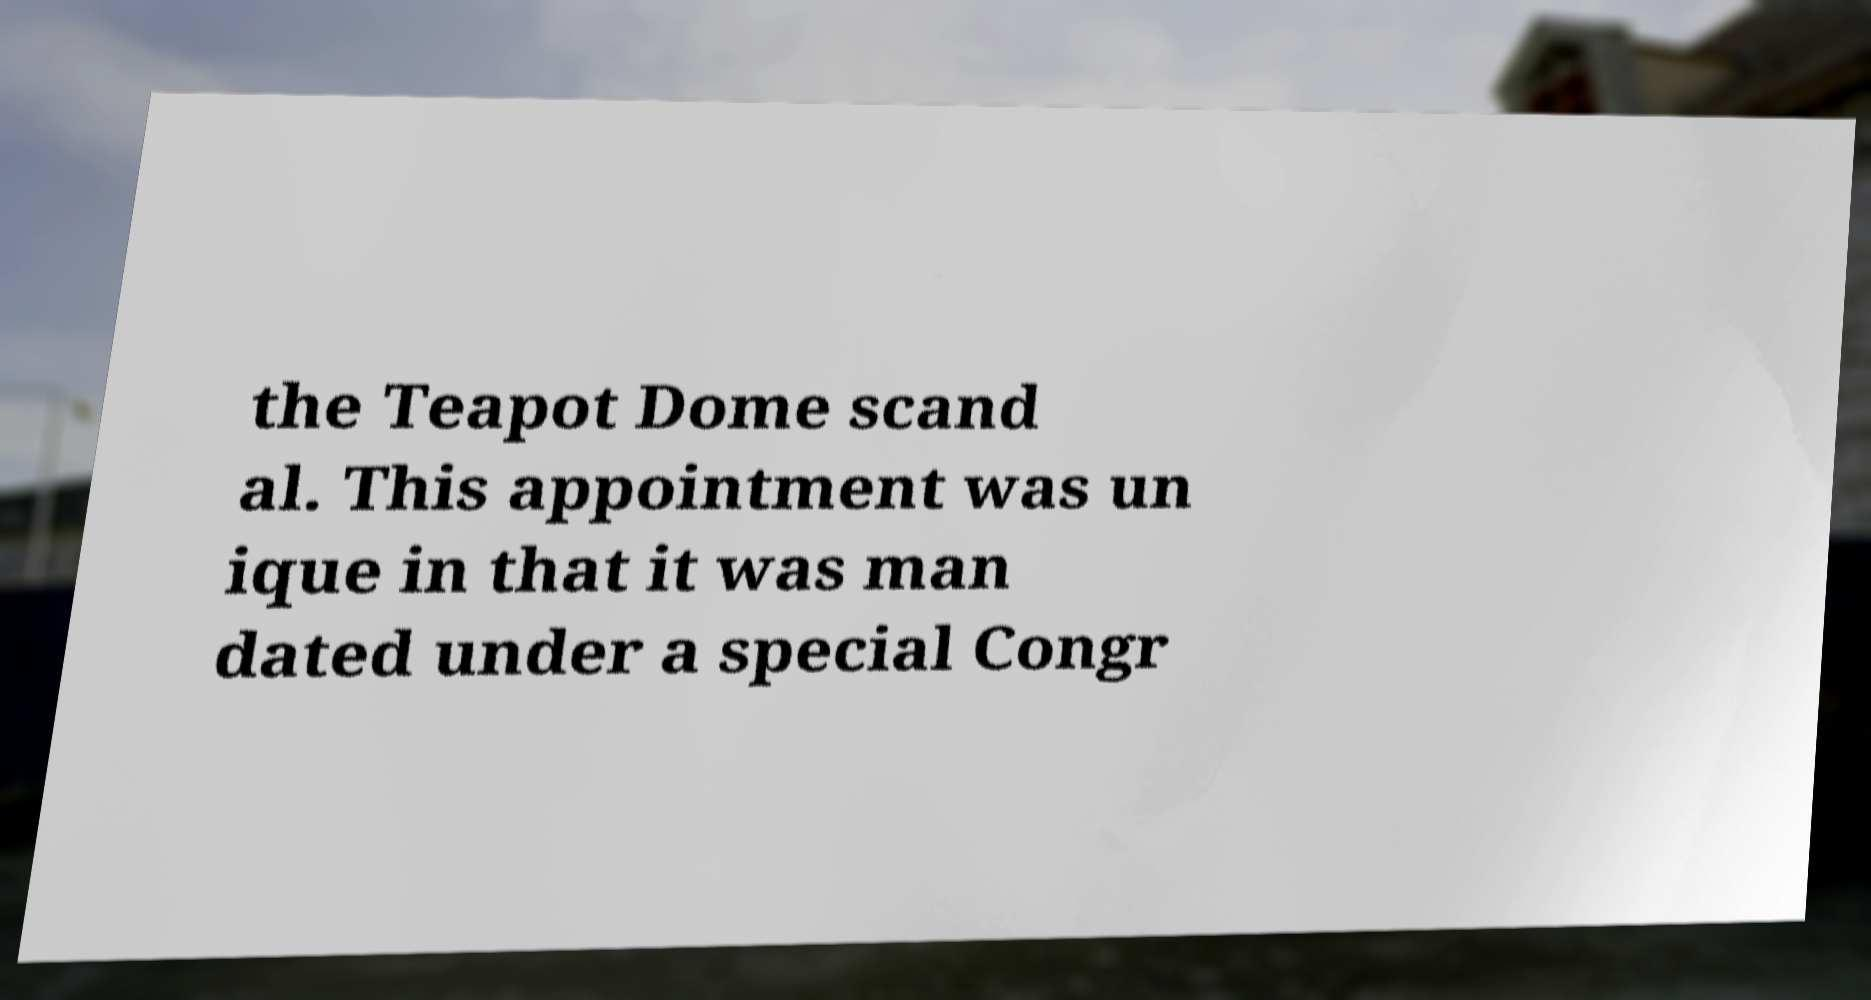Please identify and transcribe the text found in this image. the Teapot Dome scand al. This appointment was un ique in that it was man dated under a special Congr 